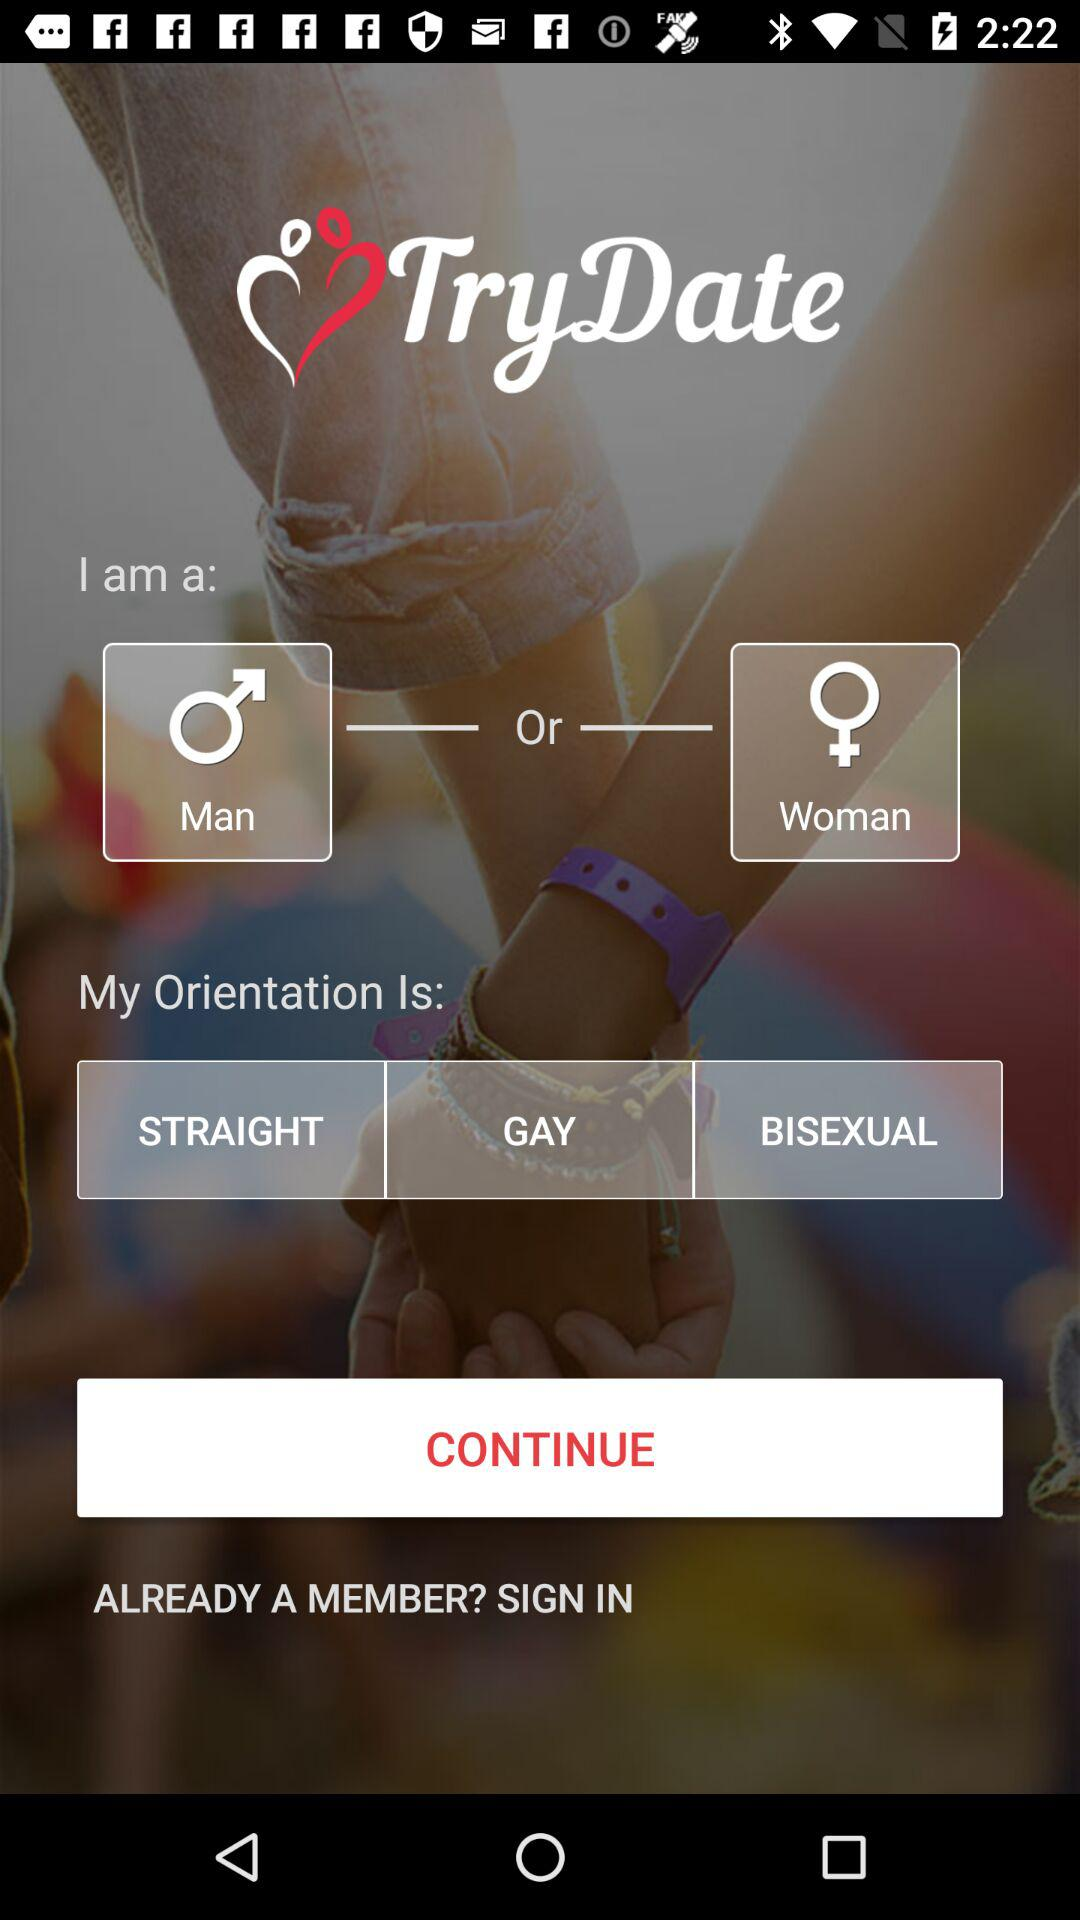How many people are members of "TryDate"?
When the provided information is insufficient, respond with <no answer>. <no answer> 